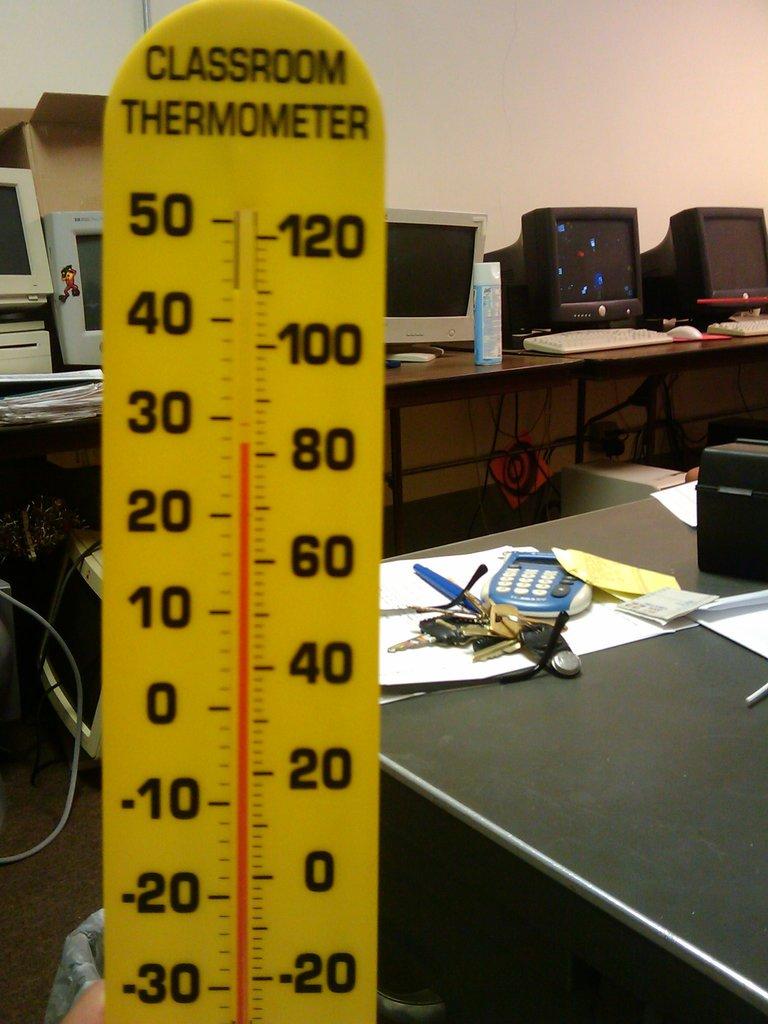Who's thermometer is this?
Make the answer very short. Classroom. What is the thermometer reading?
Ensure brevity in your answer.  81. 